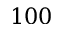Convert formula to latex. <formula><loc_0><loc_0><loc_500><loc_500>1 0 0</formula> 